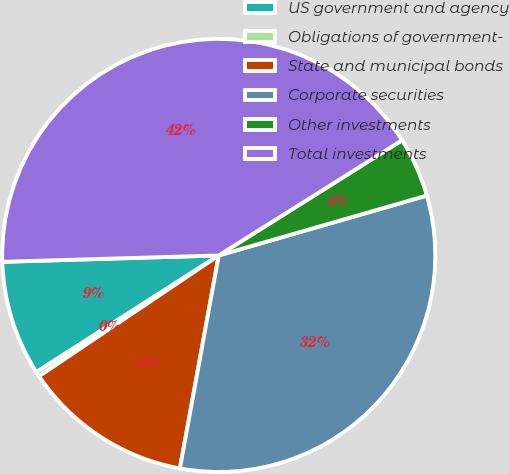<chart> <loc_0><loc_0><loc_500><loc_500><pie_chart><fcel>US government and agency<fcel>Obligations of government-<fcel>State and municipal bonds<fcel>Corporate securities<fcel>Other investments<fcel>Total investments<nl><fcel>8.59%<fcel>0.36%<fcel>12.71%<fcel>32.33%<fcel>4.47%<fcel>41.54%<nl></chart> 